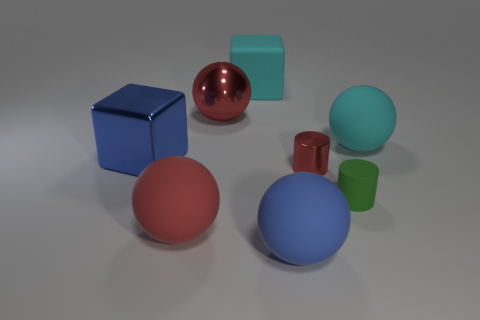Is the color of the small metallic thing the same as the big shiny sphere?
Your answer should be very brief. Yes. There is a big rubber object that is the same color as the large metallic block; what is its shape?
Offer a terse response. Sphere. There is a red ball behind the blue thing to the left of the cyan block; what is it made of?
Provide a succinct answer. Metal. There is a metal ball on the left side of the big cyan matte thing that is in front of the big red sphere behind the large blue shiny object; what is its size?
Offer a terse response. Large. Do the metal block and the matte cylinder have the same size?
Your answer should be very brief. No. There is a large cyan rubber object left of the big cyan sphere; does it have the same shape as the cyan rubber thing that is in front of the cyan cube?
Give a very brief answer. No. Are there any metal cubes left of the blue metallic thing behind the big red rubber sphere?
Offer a terse response. No. Is there a gray matte cylinder?
Offer a very short reply. No. How many cylinders have the same size as the cyan matte cube?
Give a very brief answer. 0. What number of large objects are behind the blue ball and to the right of the big red metallic ball?
Ensure brevity in your answer.  2. 